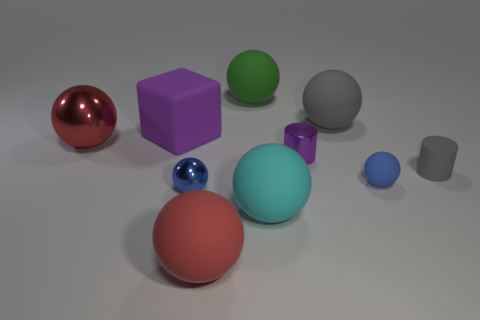Can you describe the lighting and shadows in the scene? The lighting in the scene comes primarily from the upper left as indicated by the shadows cast to the bottom right of the objects. The shadows are soft-edged, suggesting a diffused light source, and they help in giving a sense of depth and position to the shapes. 